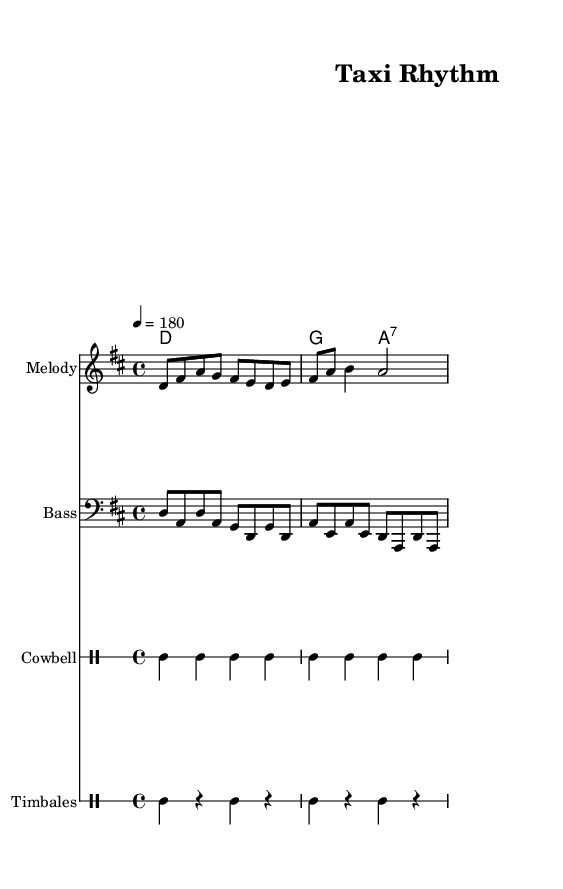What is the key signature of this music? The key signature is indicated at the beginning of the staff and shows two sharps (F# and C#), which confirms that it is D major.
Answer: D major What is the time signature of this music? The time signature is found at the beginning, indicating that there are four beats in each measure, and it is shown as 4/4.
Answer: 4/4 What is the tempo marking of this piece? The tempo marking is presented as a number with a note value (4 = 180), suggesting that quarter notes are played at a speed of 180 beats per minute.
Answer: 180 How many measures are notated in the melody? Counting the individual sections separated by vertical lines (bar lines), there are a total of 4 measures in the melody section.
Answer: 4 What instruments are used in this sheet music? The instruments are identified above their respective staves and include Melody, Bass, Cowbell, and Timbales, as indicated in the score.
Answer: Melody, Bass, Cowbell, Timbales Which rhythmic elements indicate a Latin style in this piece? The use of cowbell and timbales in the percussion parts, along with the syncopated rhythms common in Salsa and Merengue, reflect the Latin music style.
Answer: Cowbell and Timbales 